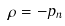<formula> <loc_0><loc_0><loc_500><loc_500>\rho = - p _ { n }</formula> 